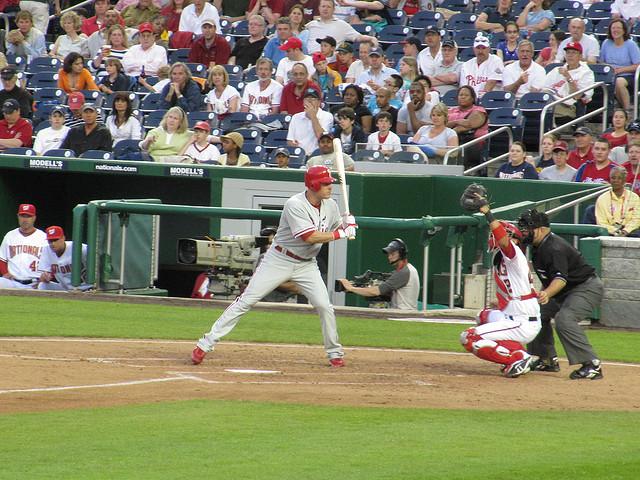What sport are they playing?
Write a very short answer. Baseball. What color helmet is the batter wearing?
Short answer required. Red. Do the spectators look bored?
Keep it brief. No. 